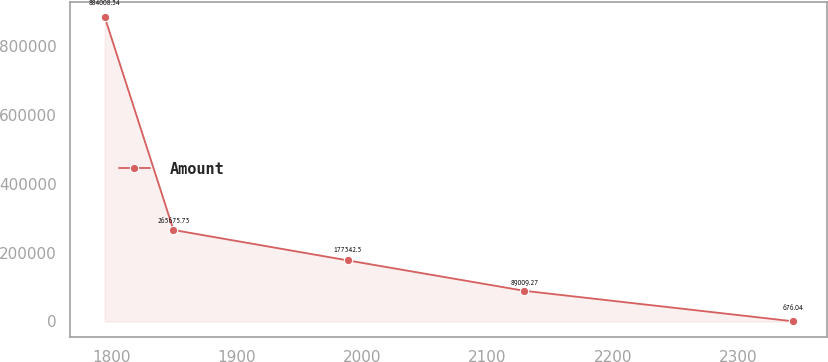<chart> <loc_0><loc_0><loc_500><loc_500><line_chart><ecel><fcel>Amount<nl><fcel>1794.6<fcel>884008<nl><fcel>1849.5<fcel>265676<nl><fcel>1988.63<fcel>177342<nl><fcel>2129.59<fcel>89009.3<nl><fcel>2343.62<fcel>676.04<nl></chart> 